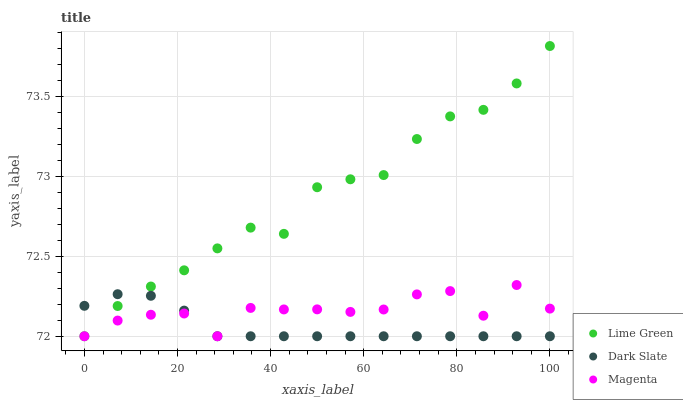Does Dark Slate have the minimum area under the curve?
Answer yes or no. Yes. Does Lime Green have the maximum area under the curve?
Answer yes or no. Yes. Does Magenta have the minimum area under the curve?
Answer yes or no. No. Does Magenta have the maximum area under the curve?
Answer yes or no. No. Is Dark Slate the smoothest?
Answer yes or no. Yes. Is Magenta the roughest?
Answer yes or no. Yes. Is Lime Green the smoothest?
Answer yes or no. No. Is Lime Green the roughest?
Answer yes or no. No. Does Dark Slate have the lowest value?
Answer yes or no. Yes. Does Lime Green have the highest value?
Answer yes or no. Yes. Does Magenta have the highest value?
Answer yes or no. No. Does Lime Green intersect Dark Slate?
Answer yes or no. Yes. Is Lime Green less than Dark Slate?
Answer yes or no. No. Is Lime Green greater than Dark Slate?
Answer yes or no. No. 